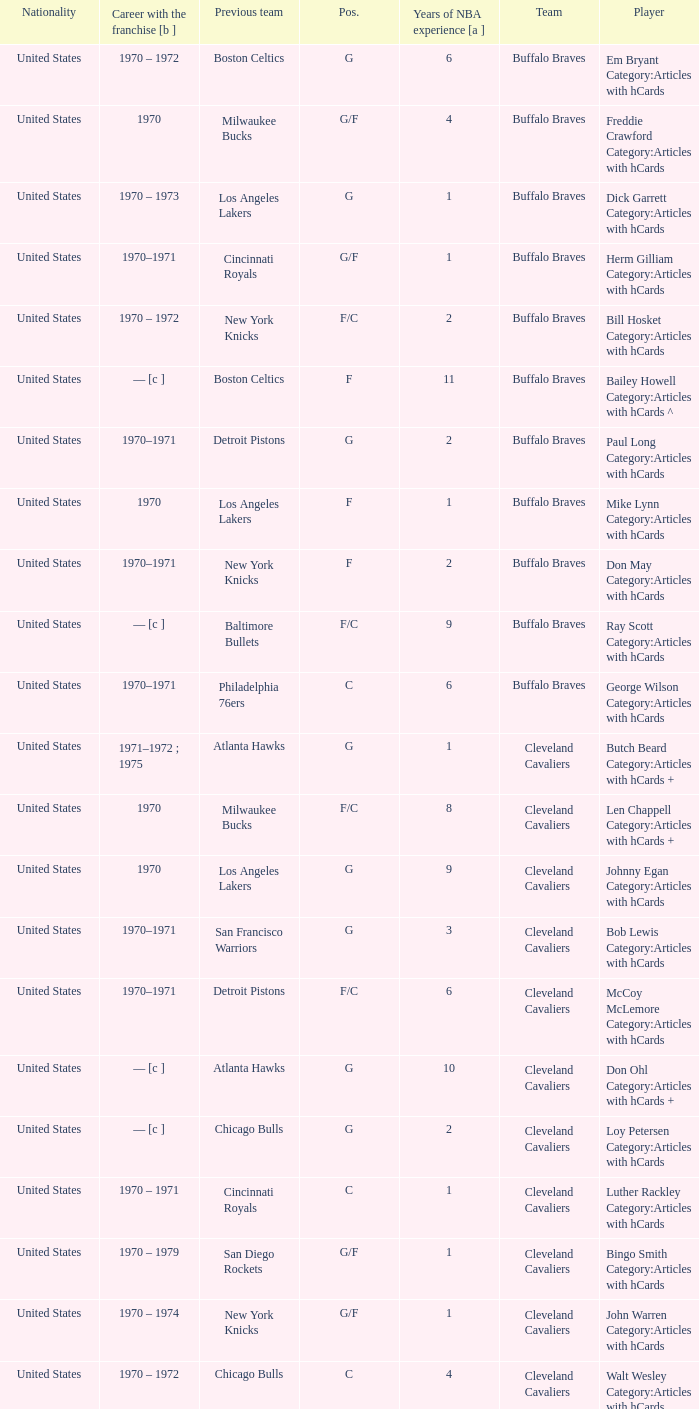Who is the player from the Buffalo Braves with the previous team Los Angeles Lakers and a career with the franchase in 1970? Mike Lynn Category:Articles with hCards. 